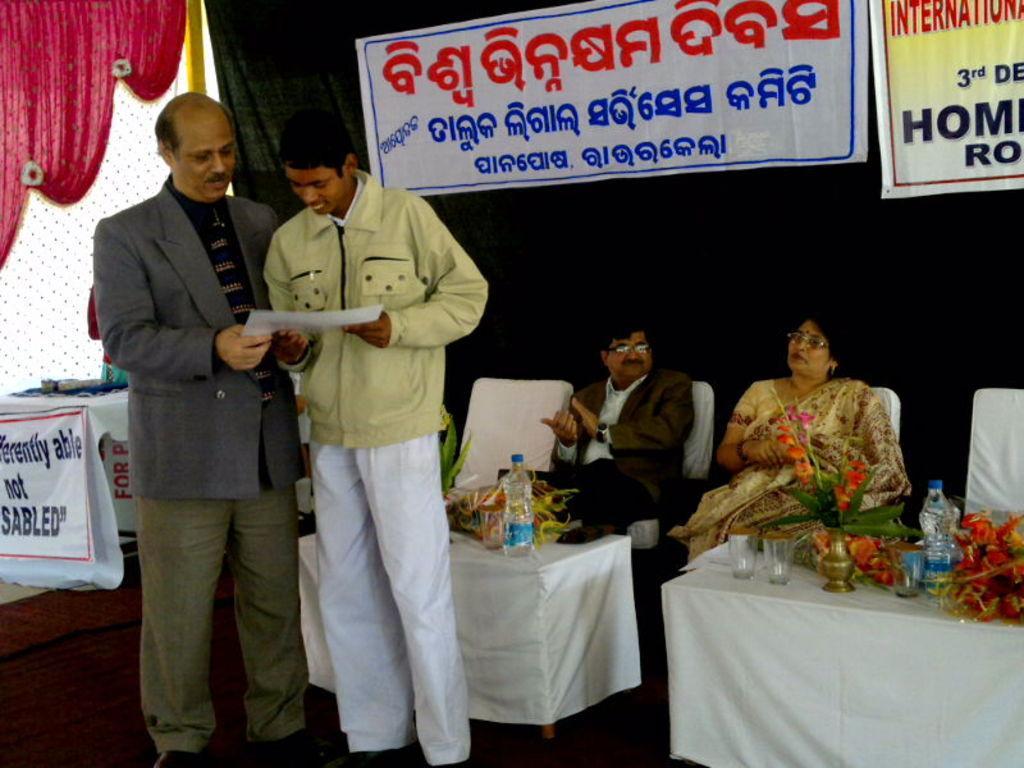In one or two sentences, can you explain what this image depicts? In the center of the image we can see two persons standing on the dais holding a paper. In the background we can see persons sitting on the chairs and we can also see tables, bottles, flower vase, glasses, banners and curtain. 